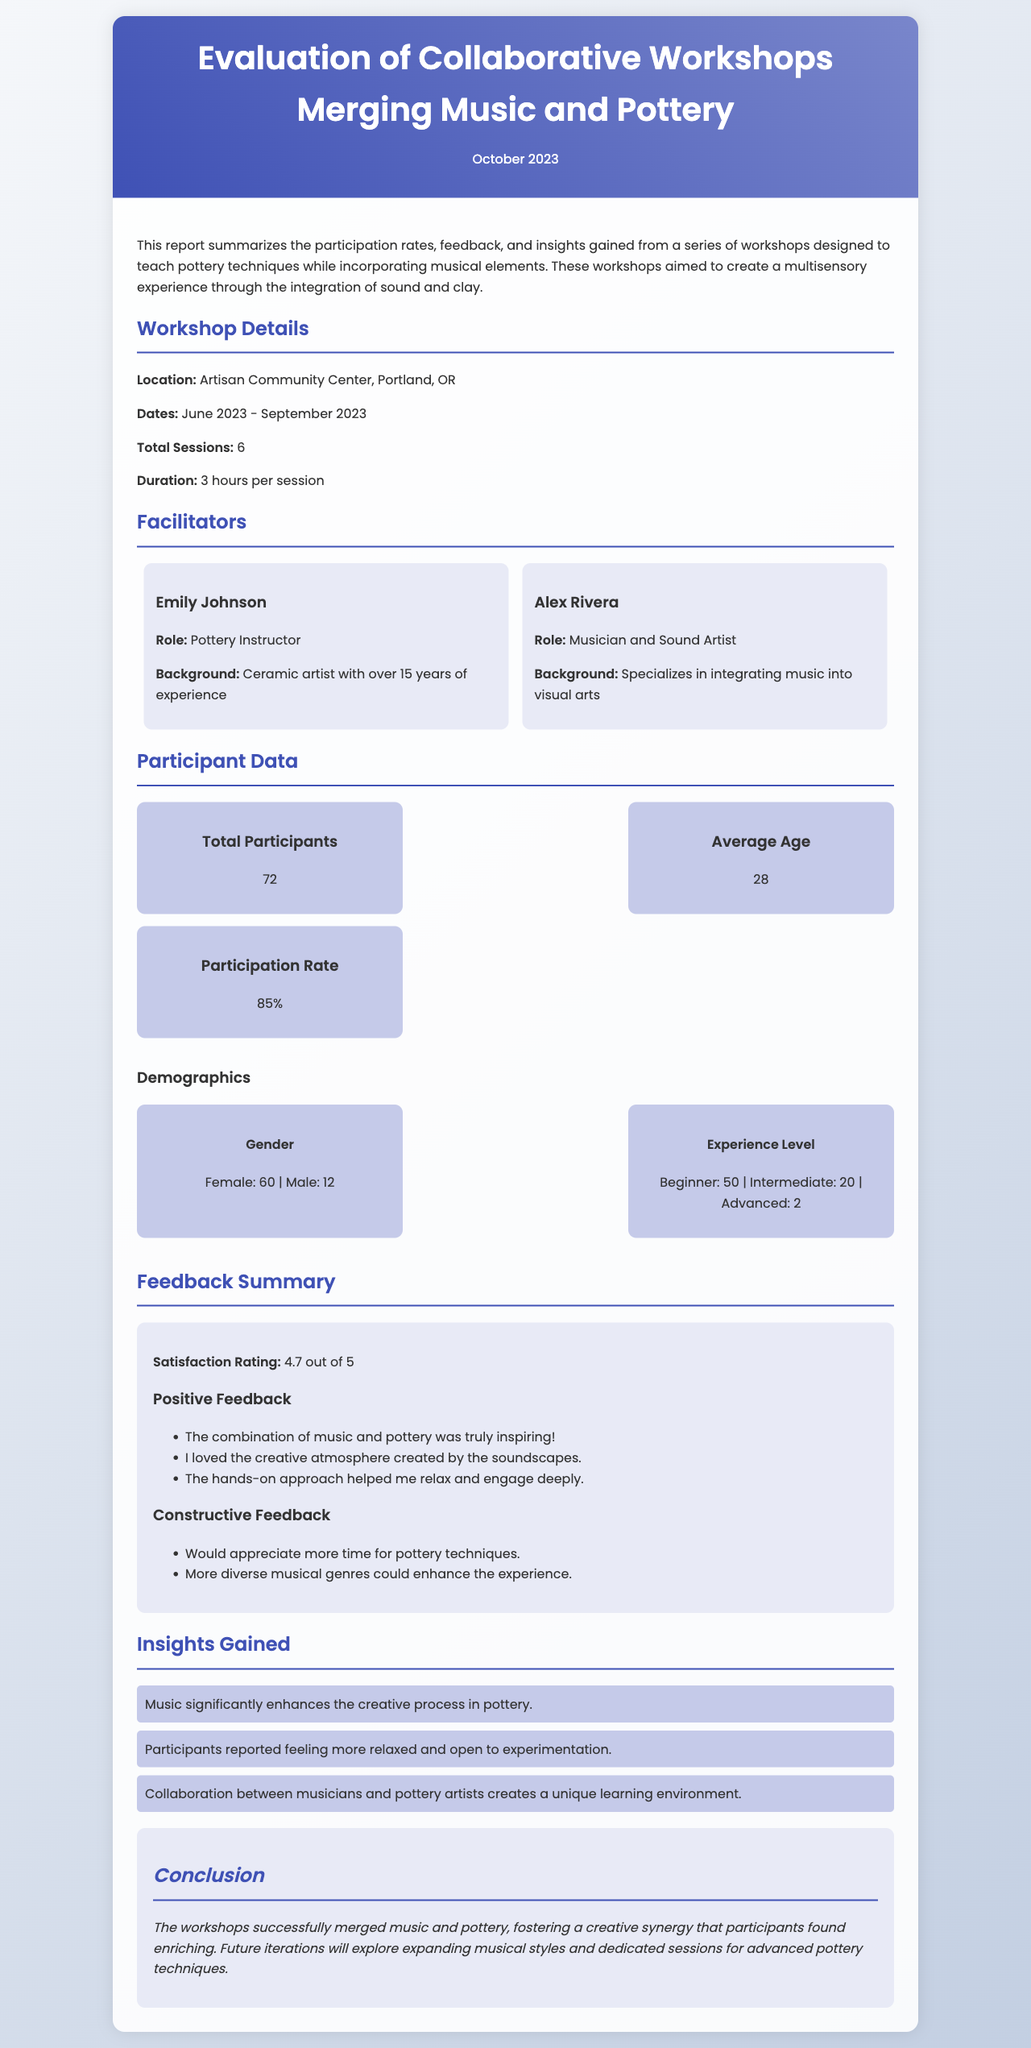what is the total number of participants? The total number of participants is listed in the document as part of the Participant Data section.
Answer: 72 what is the average age of participants? The average age is found in the Participant Data section of the report.
Answer: 28 what was the satisfaction rating from participants? The satisfaction rating is mentioned in the Feedback Summary section.
Answer: 4.7 out of 5 who are the facilitators of the workshops? The names of the facilitators along with their roles and backgrounds are provided in the Facilitators section.
Answer: Emily Johnson and Alex Rivera what is the location of the workshops? The location can be found in the Workshop Details section at the beginning of the report.
Answer: Artisan Community Center, Portland, OR how many sessions were held in total? The total number of sessions is detailed in the Workshop Details section.
Answer: 6 what is one insight gained from the workshops? Insights are listed in the Insights Gained section, summarizing feedback from participants.
Answer: Music significantly enhances the creative process in pottery what type of feedback was received regarding musical genres? The feedback about musical genres is mentioned under the Constructive Feedback section.
Answer: More diverse musical genres could enhance the experience 